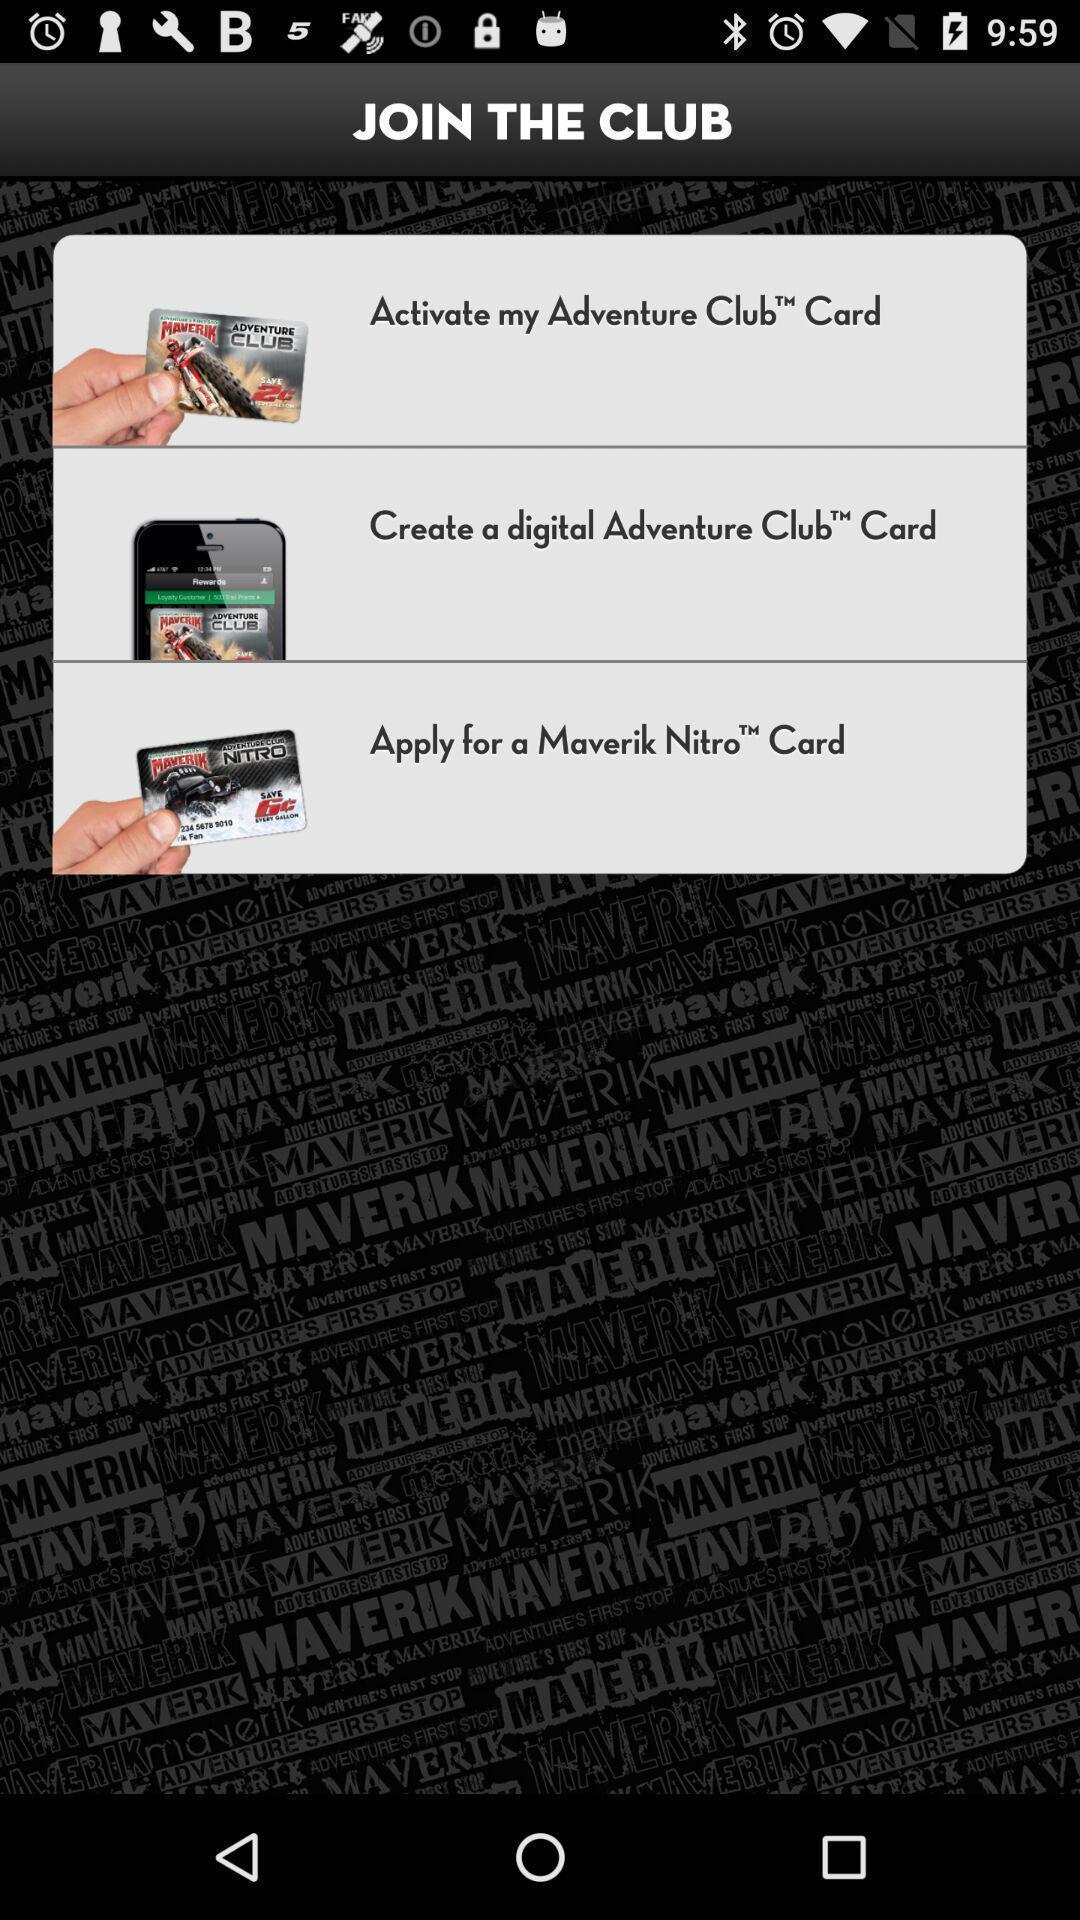Give me a summary of this screen capture. Page for joining club of a club card. 